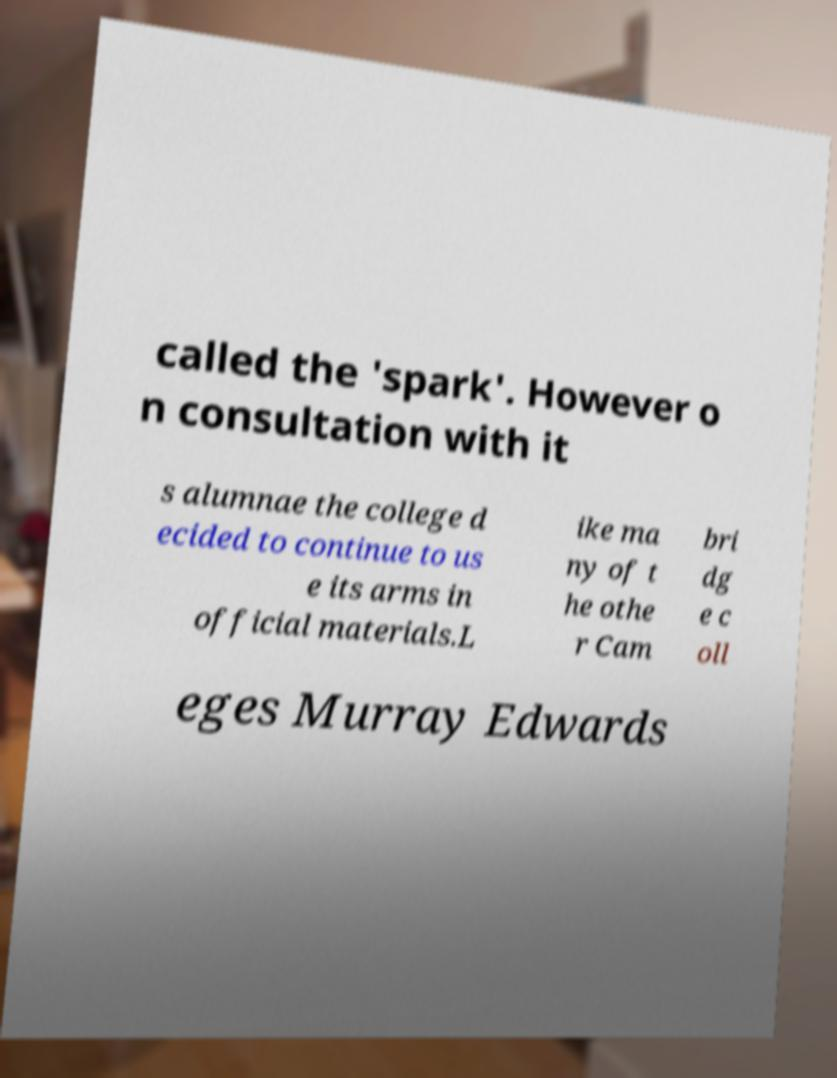Could you extract and type out the text from this image? called the 'spark'. However o n consultation with it s alumnae the college d ecided to continue to us e its arms in official materials.L ike ma ny of t he othe r Cam bri dg e c oll eges Murray Edwards 